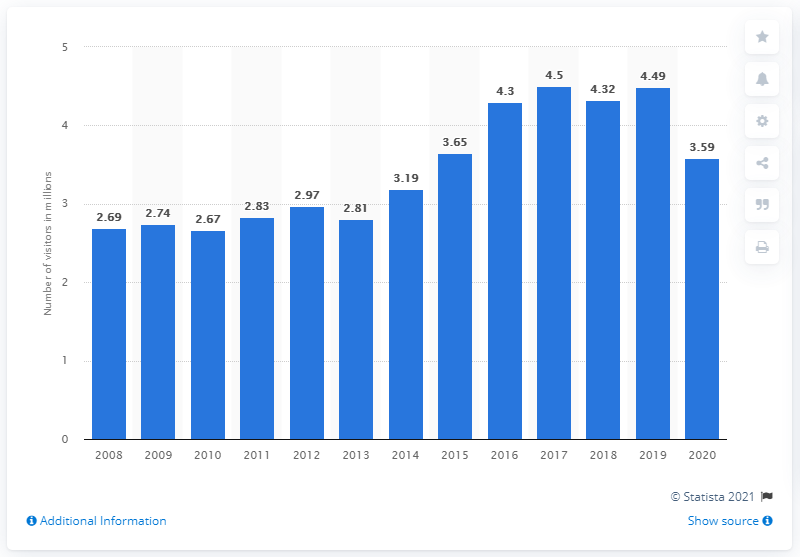Highlight a few significant elements in this photo. In 2019, Zion National Park received a total of 4,490,000 visitors. 